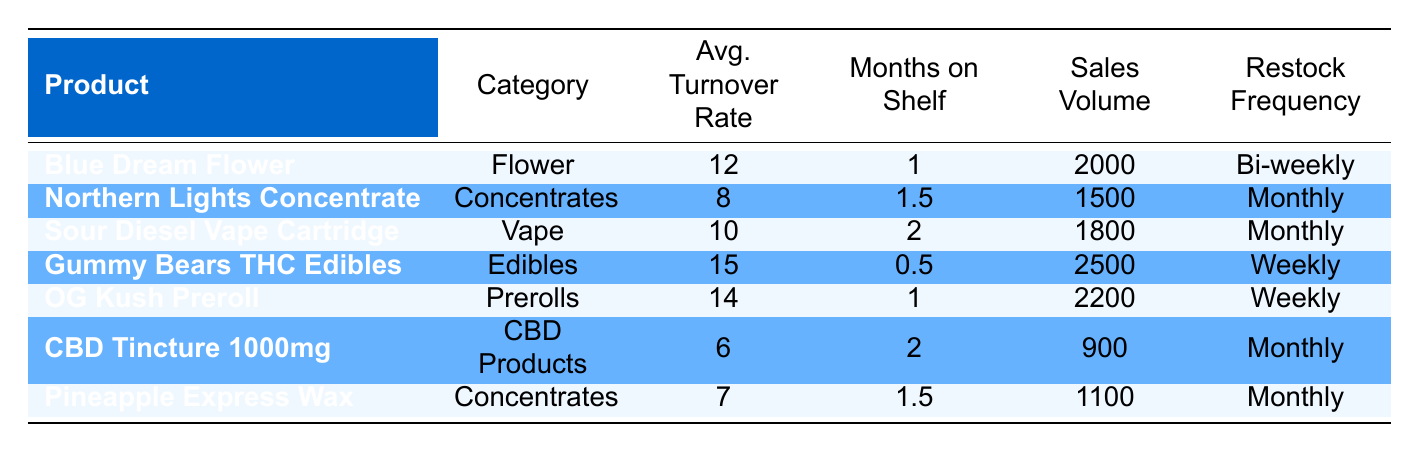What is the average turnover rate for the Gummy Bears THC Edibles? The average turnover rate for Gummy Bears THC Edibles is listed directly in the table. It is 15.
Answer: 15 Which product has the highest sales volume? By looking at the sales volume for each product, Gummy Bears THC Edibles has the highest sales volume at 2500.
Answer: 2500 Are there any products with a restock frequency of "Weekly"? The table shows that both Gummy Bears THC Edibles and OG Kush Preroll have a restock frequency of "Weekly." This means the answer is yes.
Answer: Yes What is the difference in average turnover rates between the highest and lowest products? Gummy Bears THC Edibles has the highest average turnover rate of 15, while CBD Tincture 1000mg has the lowest at 6. Therefore, the difference is 15 - 6 = 9.
Answer: 9 How many products have an average turnover rate greater than 10? We can count the products with an average turnover rate of greater than 10 by checking each product's turnover rate. These products are Blue Dream Flower, Gummy Bears THC Edibles, OG Kush Preroll. Thus, there are 3 such products.
Answer: 3 Is the sales volume for Northern Lights Concentrate greater than that of Pineapple Express Wax? Northern Lights Concentrate has a sales volume of 1500, and Pineapple Express Wax has a sales volume of 1100. Since 1500 is greater than 1100, the answer is yes.
Answer: Yes What is the average sales volume for all products? First, we add the sales volumes: 2000 + 1500 + 1800 + 2500 + 2200 + 900 + 1100 = 10900. Then we divide by the number of products (7): 10900 / 7 = 1557.14. Therefore, the average sales volume is approximately 1557.14.
Answer: 1557.14 Which cannabis category has products with an average turnover rate of less than 7? The table shows that CBD Products (6) and Concentrates (7, Pineapple Express Wax) are two categories that feature products with an average turnover rate of less than 7. However, only CBD Products meets the criteria strictly with 6.
Answer: CBD Products What is the longest time that any product has been on the shelf? The table indicates that Sour Diesel Vape Cartridge and CBD Tincture 1000mg have both been on the shelf for the longest time at 2 months.
Answer: 2 months 